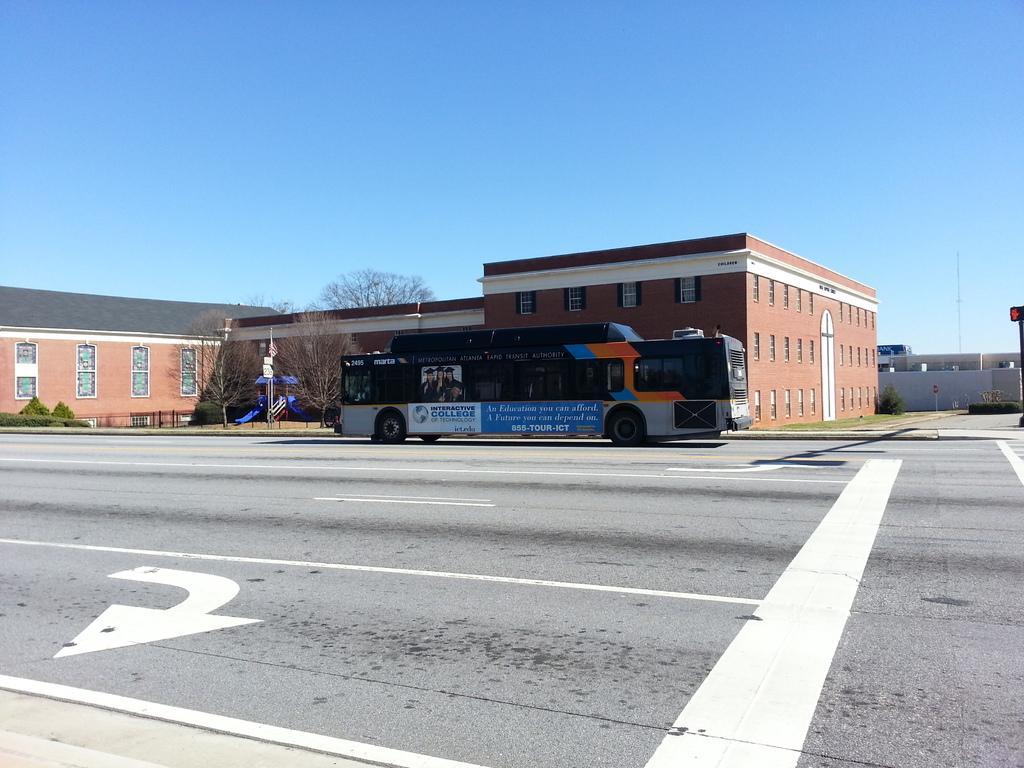Could you give a brief overview of what you see in this image? In the background we can a clear blue sky. Here we can see a building with windows. Here we can see a bus on the road. At the right side of the picture we can see a plant and wall. 